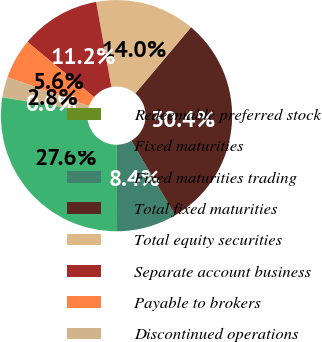<chart> <loc_0><loc_0><loc_500><loc_500><pie_chart><fcel>Redeemable preferred stock<fcel>Fixed maturities<fcel>Fixed maturities trading<fcel>Total fixed maturities<fcel>Total equity securities<fcel>Separate account business<fcel>Payable to brokers<fcel>Discontinued operations<nl><fcel>0.04%<fcel>27.6%<fcel>8.4%<fcel>30.38%<fcel>13.97%<fcel>11.18%<fcel>5.61%<fcel>2.83%<nl></chart> 